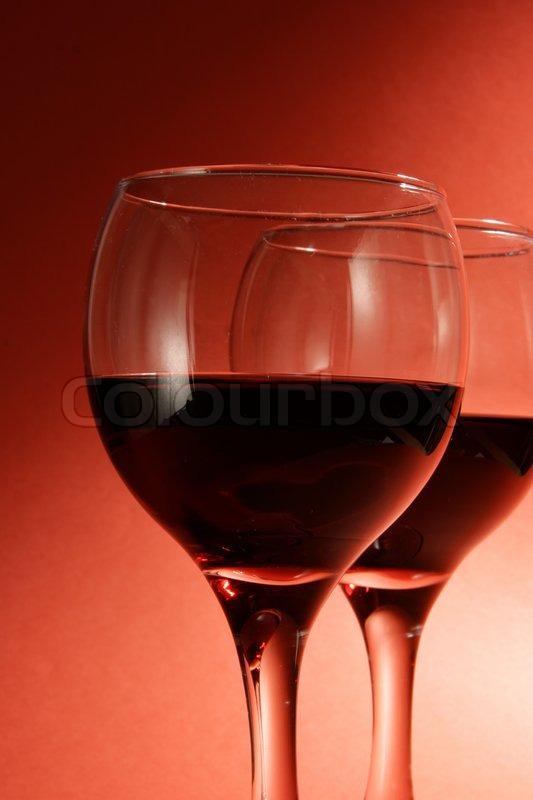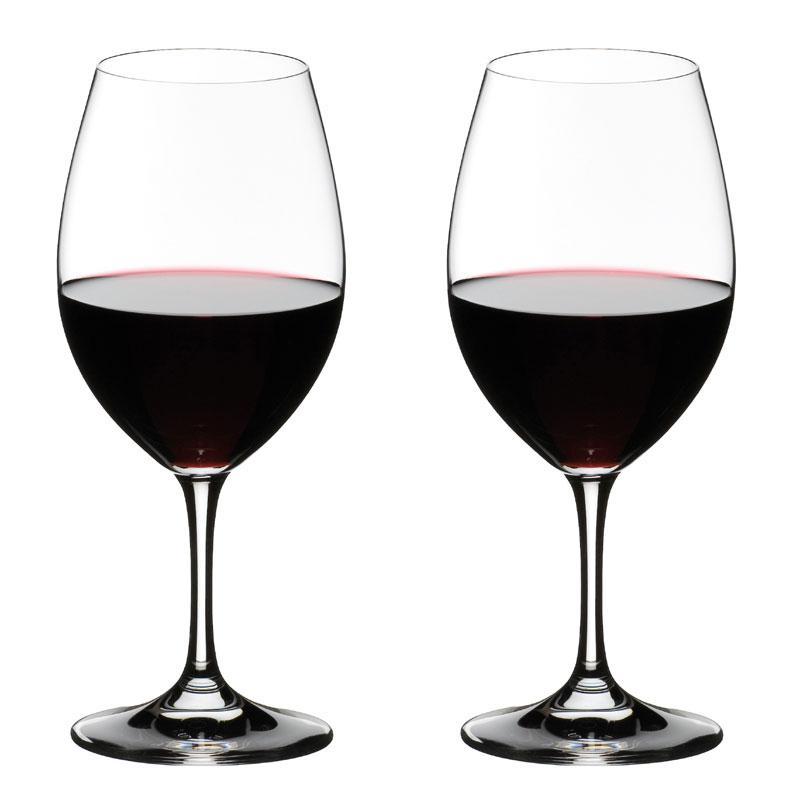The first image is the image on the left, the second image is the image on the right. Examine the images to the left and right. Is the description "There is one pair of overlapping glasses containing level liquids, and one pair of glasses that do not overlap." accurate? Answer yes or no. Yes. The first image is the image on the left, the second image is the image on the right. Assess this claim about the two images: "Two glasses are angled toward each other in one of the images.". Correct or not? Answer yes or no. No. 